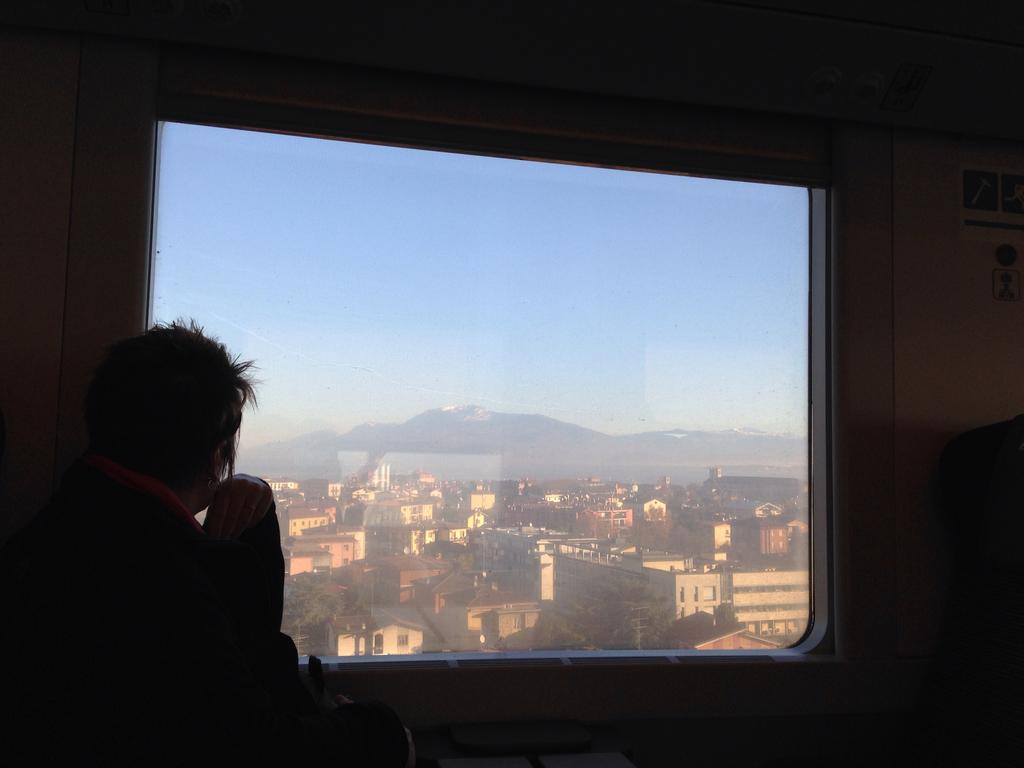What is present in the image along with the person? There is a screen and a poster on the wall in the image. What is displayed on the screen? The screen displays buildings, trees, mountains, and the sky. What can be seen on the wall in the image? There is a poster on the wall in the image. What other objects are present in the image? There are objects in the image, but their specific details are not mentioned in the facts. What time of day is it in the image, and is the person laughing? The time of day is not mentioned in the image, and there is no indication of the person laughing. 